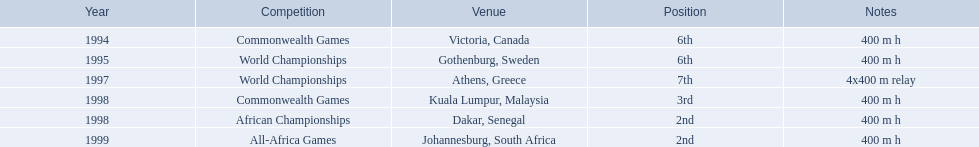In which years did ken harder participate? 1994, 1995, 1997, 1998, 1998, 1999. For the 1997 relay, what was the distance covered? 4x400 m relay. 